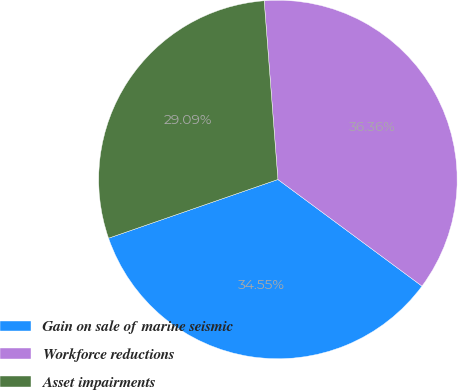<chart> <loc_0><loc_0><loc_500><loc_500><pie_chart><fcel>Gain on sale of marine seismic<fcel>Workforce reductions<fcel>Asset impairments<nl><fcel>34.55%<fcel>36.36%<fcel>29.09%<nl></chart> 